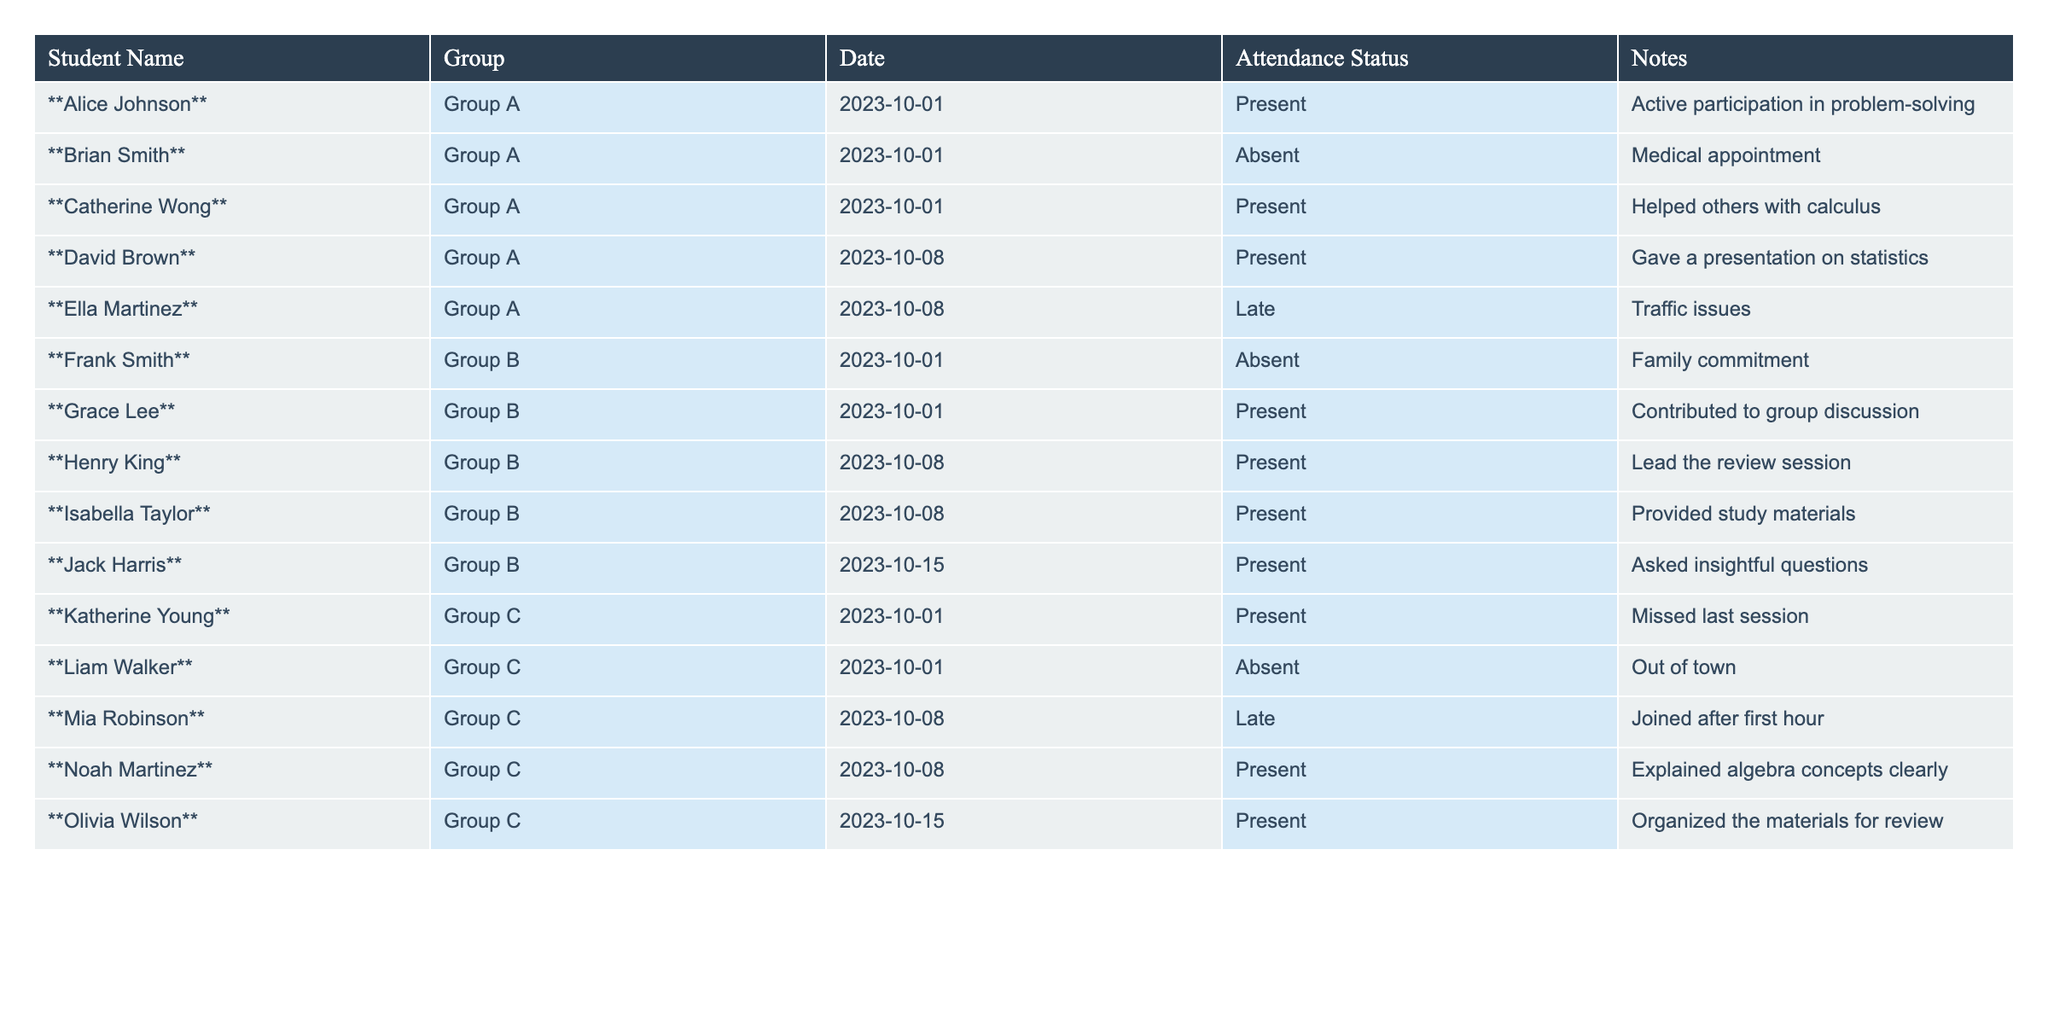What is the attendance status of Alice Johnson on 2023-10-01? According to the table, Alice Johnson's attendance status on this date is listed as "Present."
Answer: Present How many students from Group A were present on 2023-10-01? The table indicates that out of three students in Group A on that date, Alice Johnson and Catherine Wong were present. Therefore, the total is 2.
Answer: 2 Did Frank Smith attend the Group B meeting on 2023-10-01? By checking the table, Frank Smith's attendance status for this date is "Absent," meaning he did not attend the meeting.
Answer: No Who helped others with calculus? The table shows that Catherine Wong helped others with calculus in Group A on 2023-10-01.
Answer: Catherine Wong What is the total number of students who were late across all groups? To find the total, we check the attendance statuses for "Late." Mia Robinson from Group C was late on 2023-10-08 and Ella Martinez from Group A was late on the same date. Thus, the total count is 2 late students.
Answer: 2 What group had the highest number of presents on 2023-10-08? Checking the attendance statuses for this date: Group A had 2 presents, Group B had 2 presents, and Group C had 1 present. Therefore, Groups A and B are tied for the highest.
Answer: Groups A and B Is there anyone who attended every meeting listed in the table? Analyzing the attendance records, no student is marked present for every meeting on the given dates; hence the answer is no.
Answer: No Which student provided study materials in Group B? The table states that Isabella Taylor provided study materials in Group B on 2023-10-08.
Answer: Isabella Taylor What was the total number of absences in Group C? In Group C, Liam Walker was absent on 2023-10-01 and Mia Robinson was late but attended on 2023-10-08. Therefore, there is only 1 absence recorded.
Answer: 1 Calculate the total number of unique students listed across all groups. The table has 12 unique students listed: Alice Johnson, Brian Smith, Catherine Wong, David Brown, Ella Martinez, Frank Smith, Grace Lee, Henry King, Isabella Taylor, Jack Harris, Katherine Young, Liam Walker, Mia Robinson, Noah Martinez, and Olivia Wilson, giving a total of 12.
Answer: 12 Which student's notes mentioned traffic issues? According to the table, Ella Martinez's notes on 2023-10-08 mentioned traffic issues, indicating she was late for the meeting.
Answer: Ella Martinez 